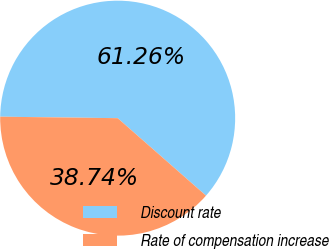Convert chart to OTSL. <chart><loc_0><loc_0><loc_500><loc_500><pie_chart><fcel>Discount rate<fcel>Rate of compensation increase<nl><fcel>61.26%<fcel>38.74%<nl></chart> 